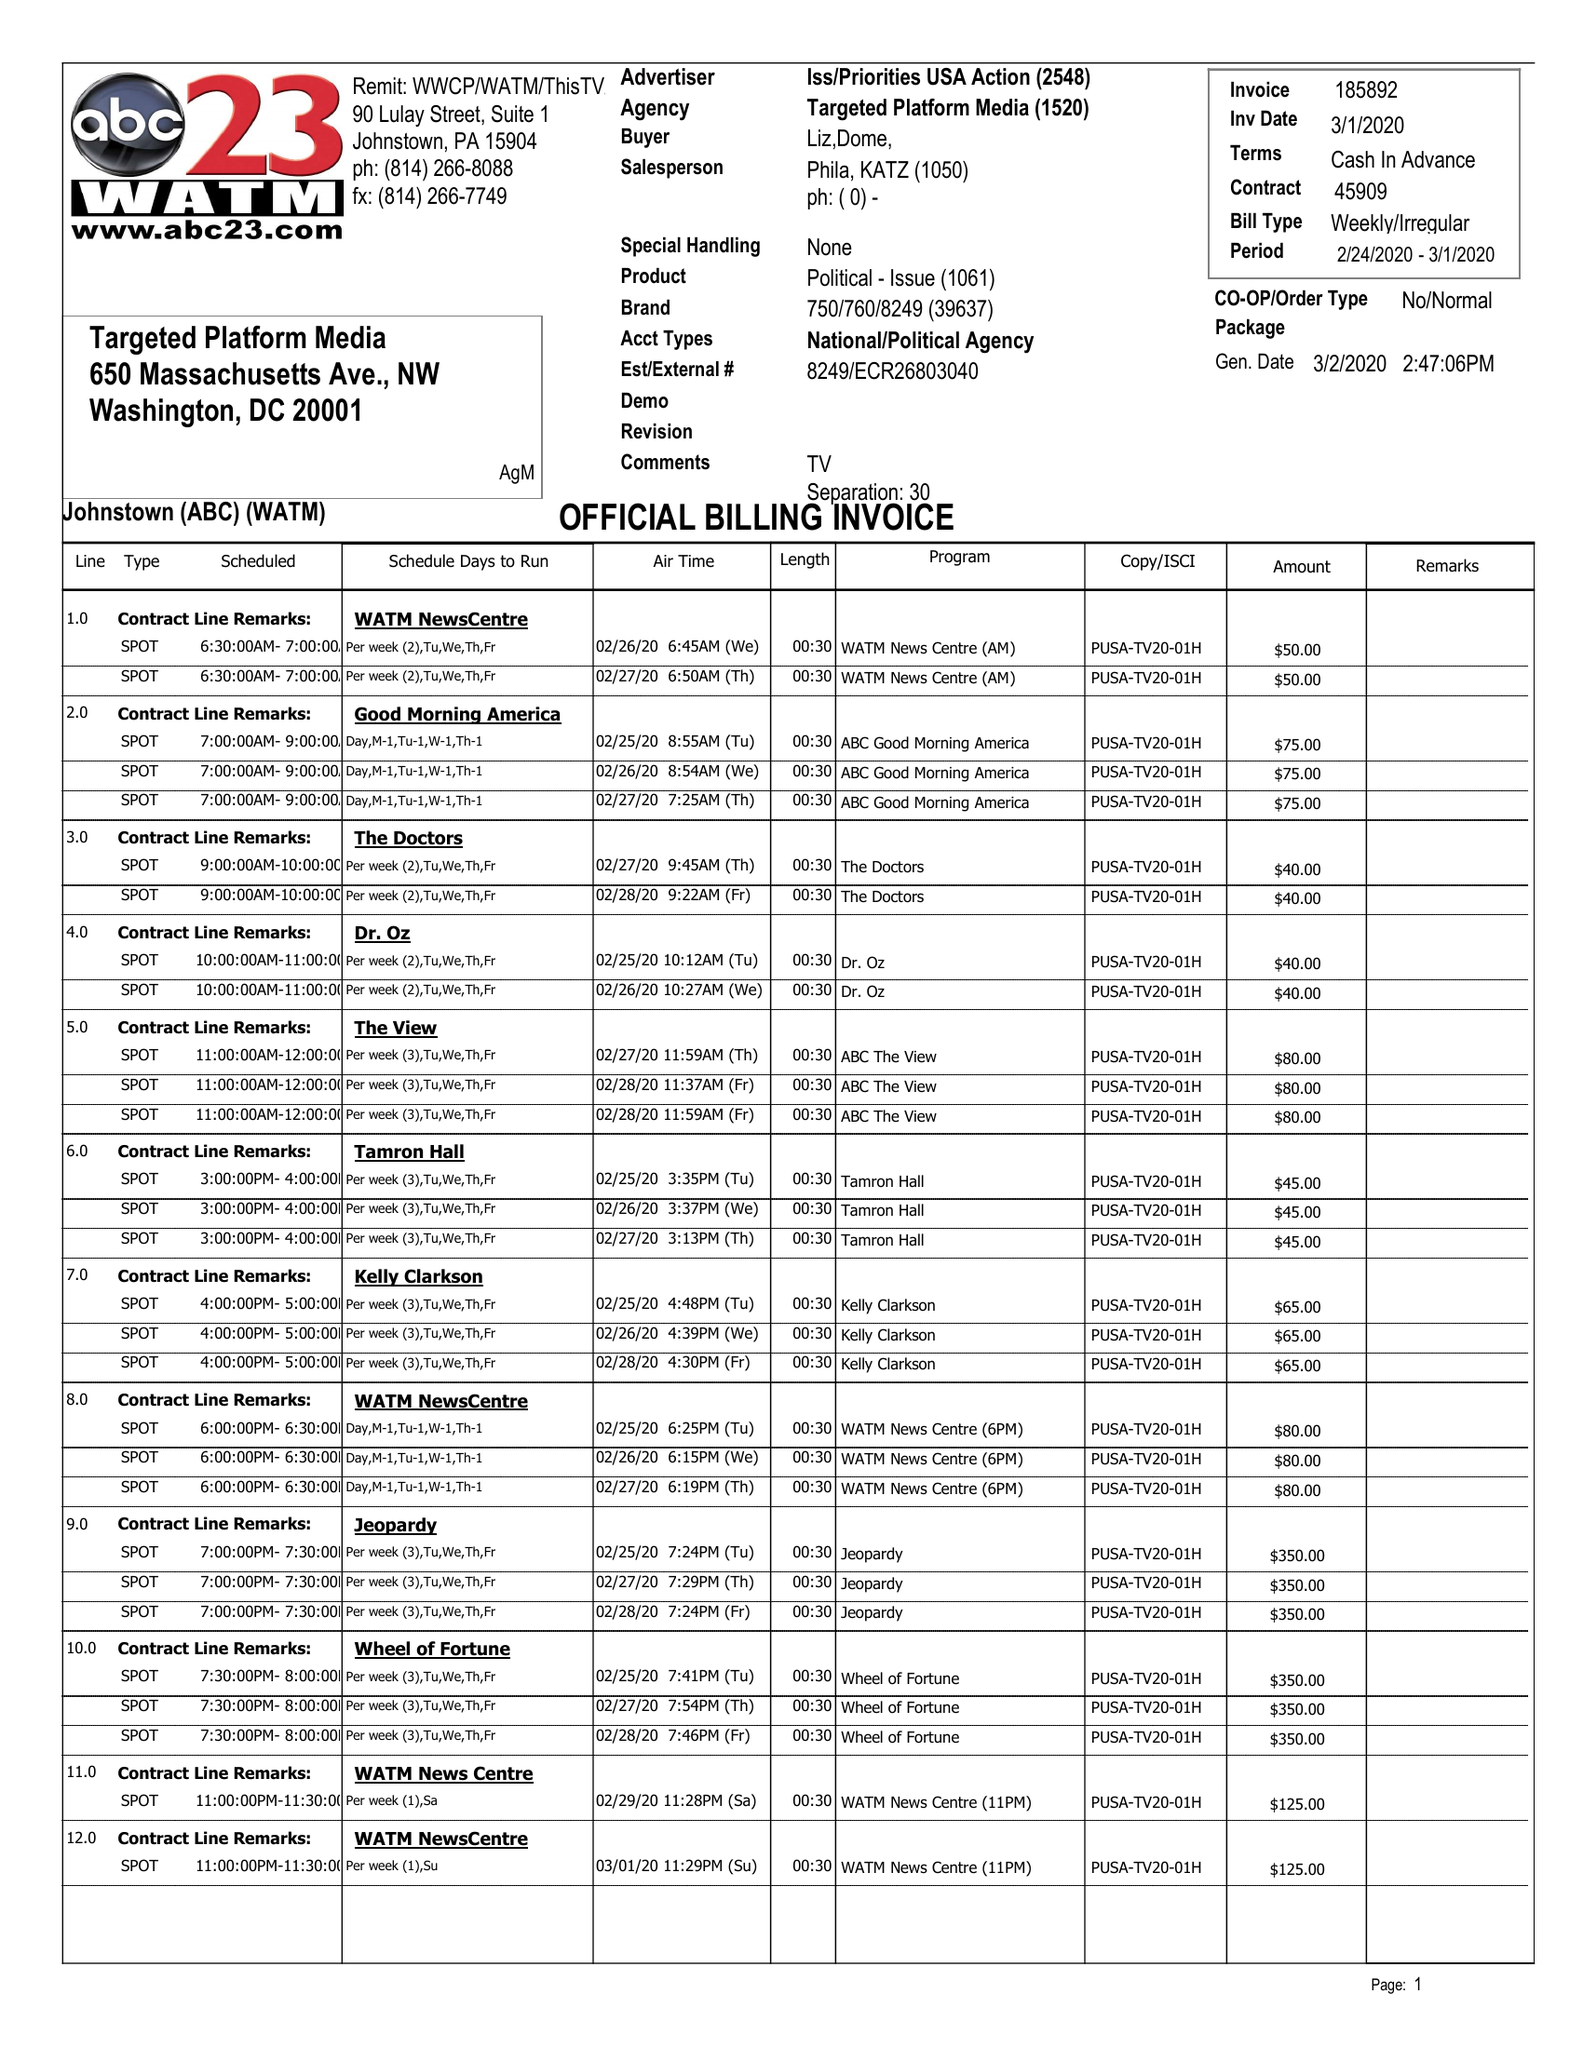What is the value for the advertiser?
Answer the question using a single word or phrase. ISS/PRIORITIESUSAACTION 